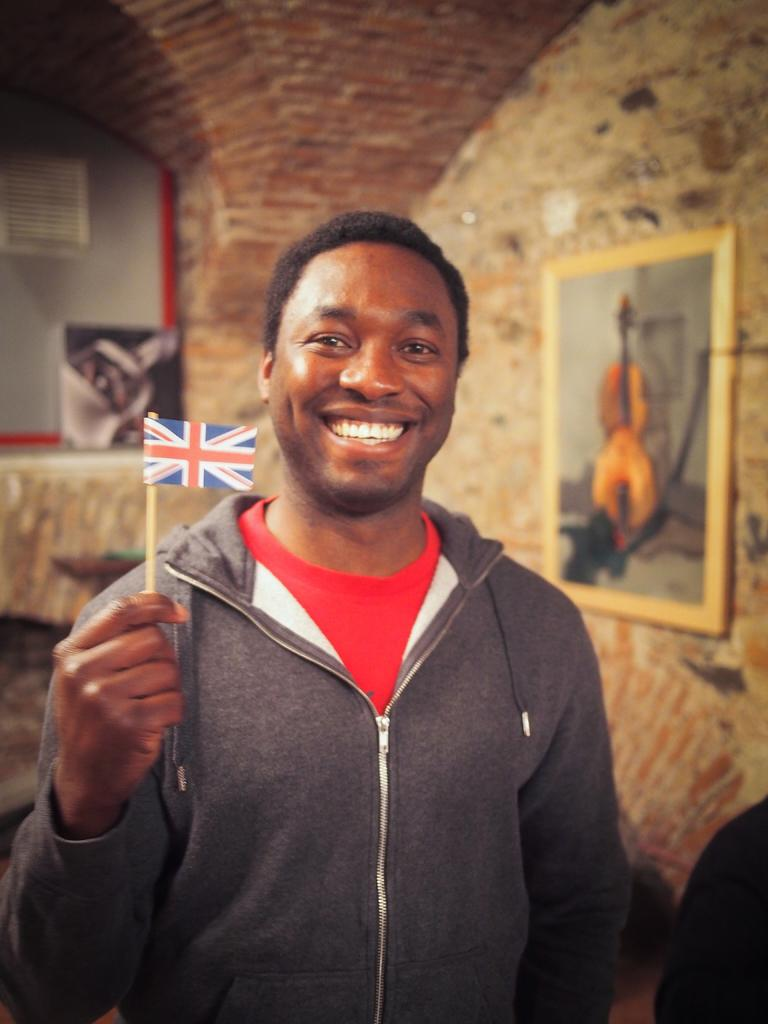Who is the main subject in the image? There is a man in the center of the image. What is the man holding in his hand? The man is holding a small flag in his hand. What can be seen in the background of the image? There are portraits in the background of the image. What type of ball is the man playing with in the image? There is no ball present in the image; the man is holding a small flag. Can you see any bees in the image? There are no bees visible in the image. 